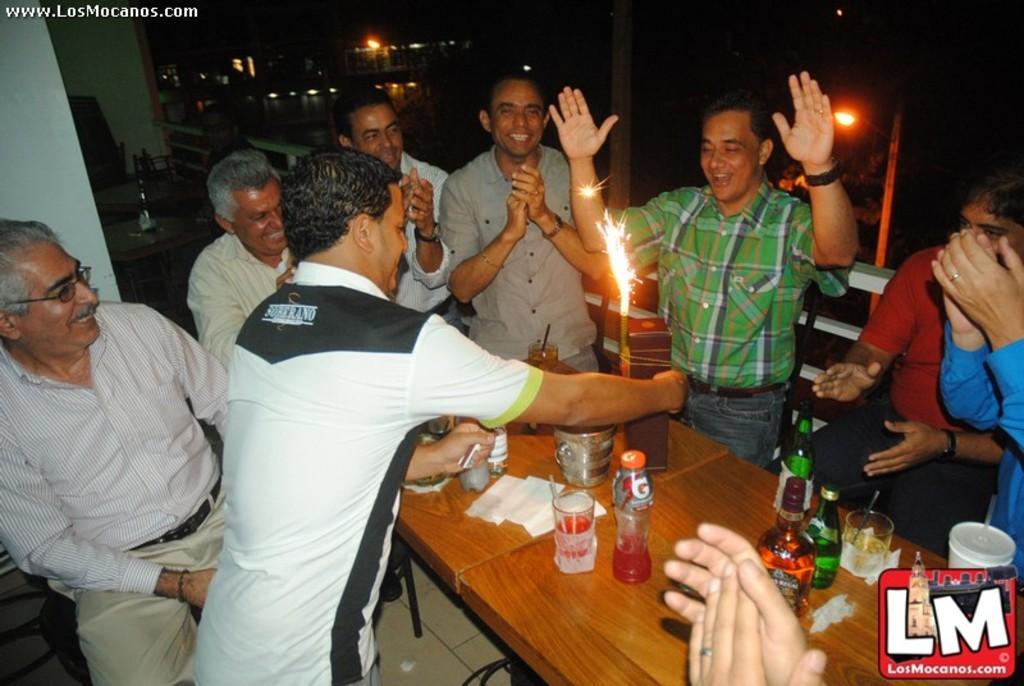Describe this image in one or two sentences. In this image there are a few people standing are clapping and laughing, in front of them on the table there are bottles, glasses, candles and some other objects, behind them there are tables and chairs, on the tables there are some objects, beside the table there is a metal rod fence, behind them there are lamp posts, trees and buildings, on the top left of the image there is some text, on the bottom right of the image there is a logo. 